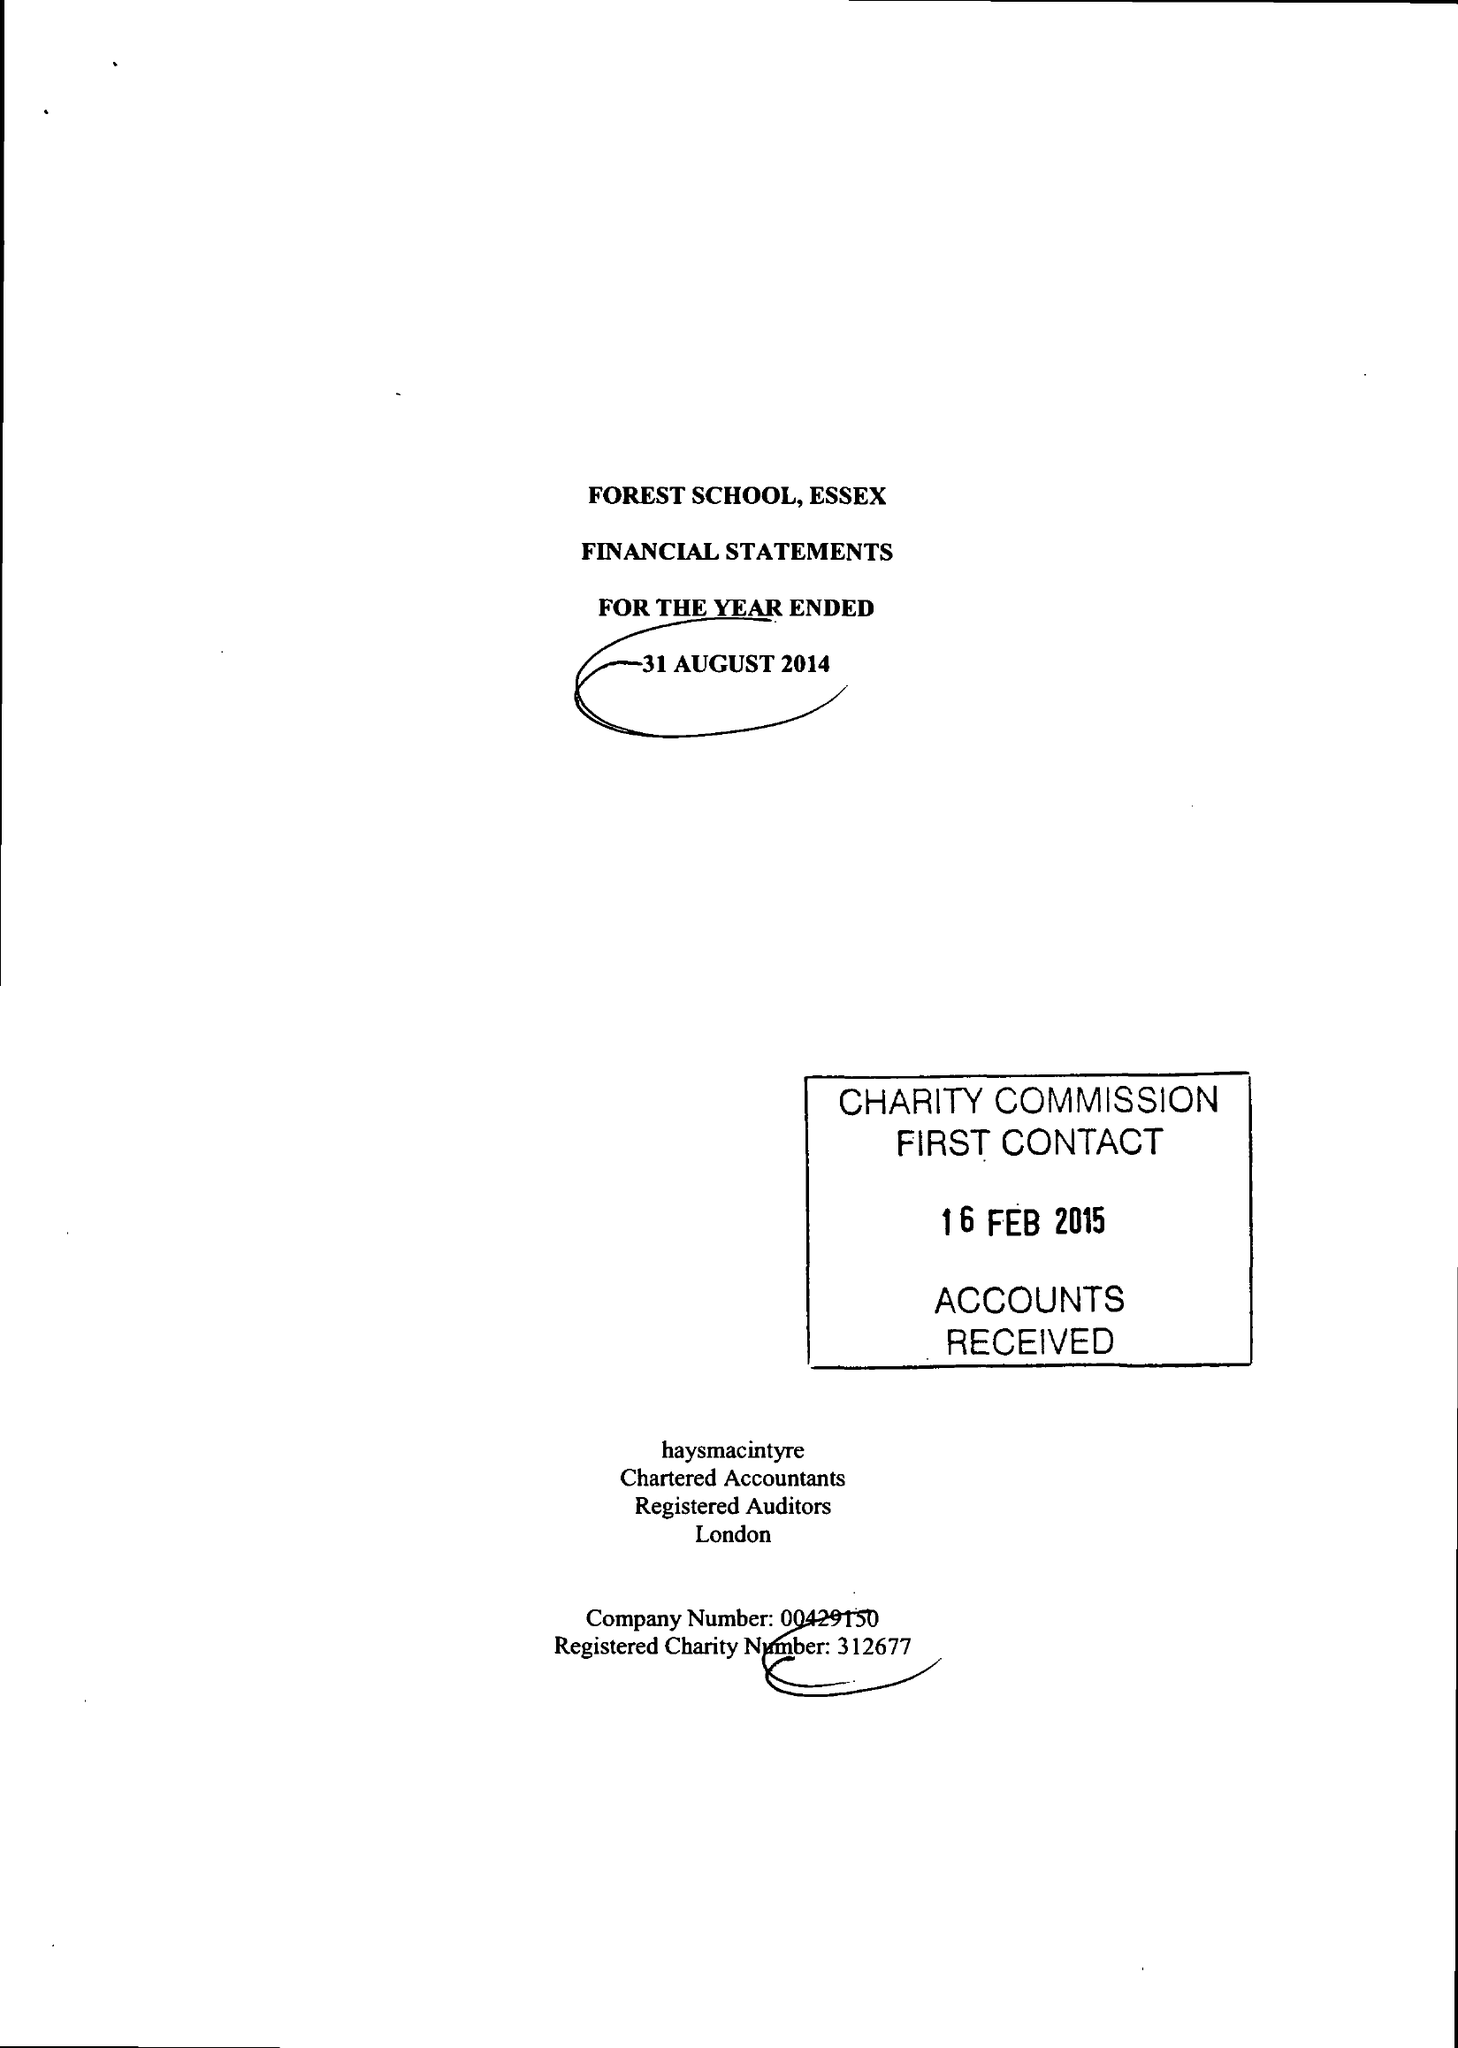What is the value for the charity_name?
Answer the question using a single word or phrase. Forest School, Essex 